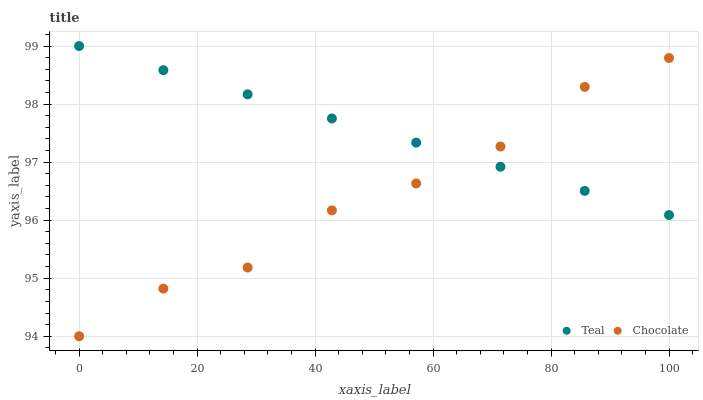Does Chocolate have the minimum area under the curve?
Answer yes or no. Yes. Does Teal have the maximum area under the curve?
Answer yes or no. Yes. Does Chocolate have the maximum area under the curve?
Answer yes or no. No. Is Teal the smoothest?
Answer yes or no. Yes. Is Chocolate the roughest?
Answer yes or no. Yes. Is Chocolate the smoothest?
Answer yes or no. No. Does Chocolate have the lowest value?
Answer yes or no. Yes. Does Teal have the highest value?
Answer yes or no. Yes. Does Chocolate have the highest value?
Answer yes or no. No. Does Teal intersect Chocolate?
Answer yes or no. Yes. Is Teal less than Chocolate?
Answer yes or no. No. Is Teal greater than Chocolate?
Answer yes or no. No. 